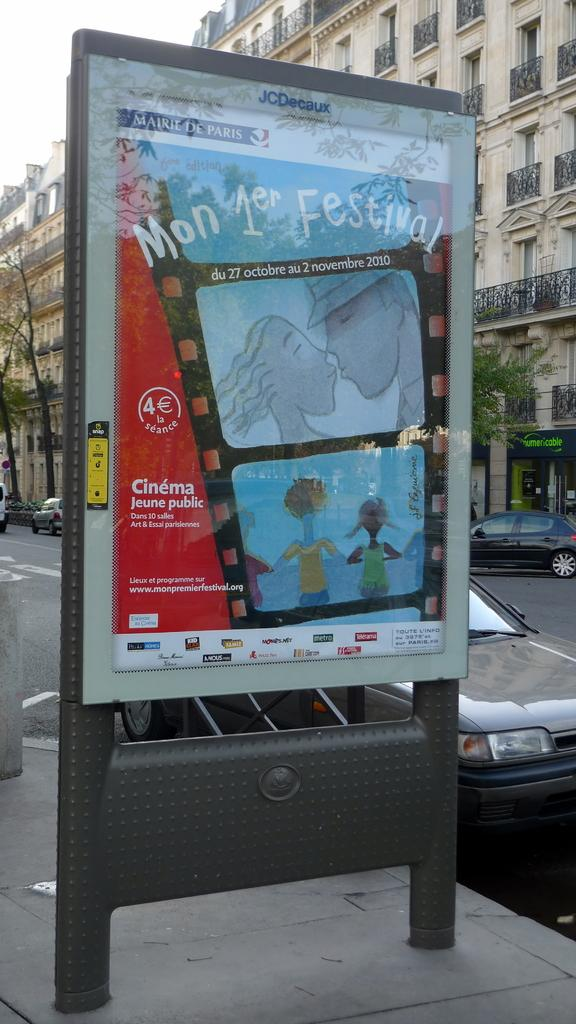Provide a one-sentence caption for the provided image. An advertisement for a festival on a city sidewalk. 